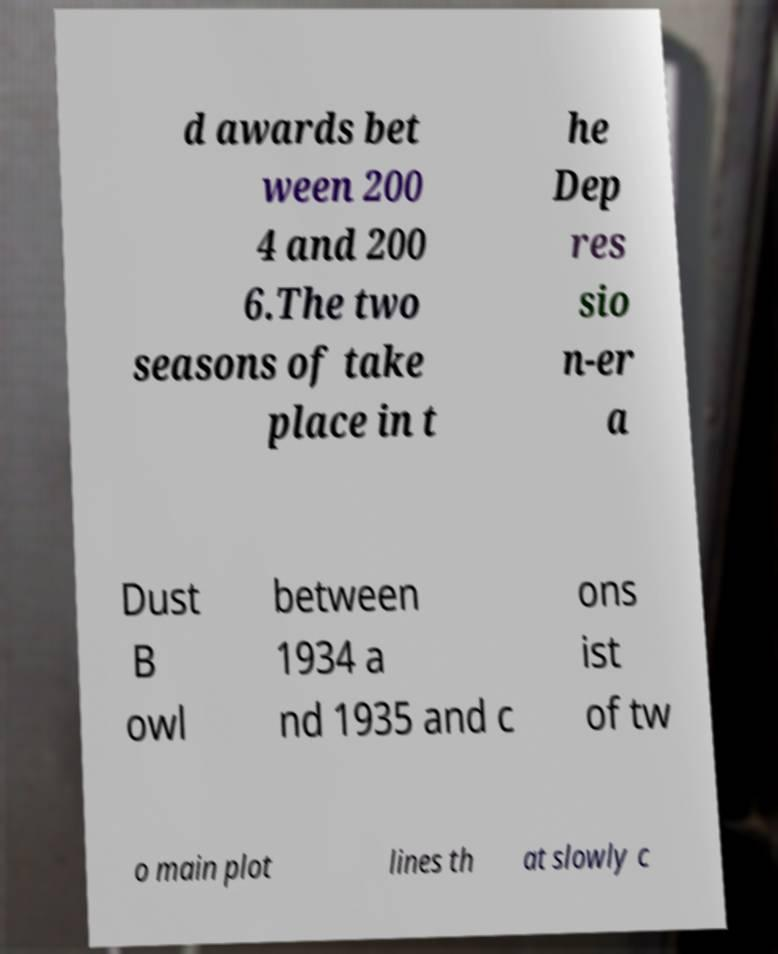Please identify and transcribe the text found in this image. d awards bet ween 200 4 and 200 6.The two seasons of take place in t he Dep res sio n-er a Dust B owl between 1934 a nd 1935 and c ons ist of tw o main plot lines th at slowly c 